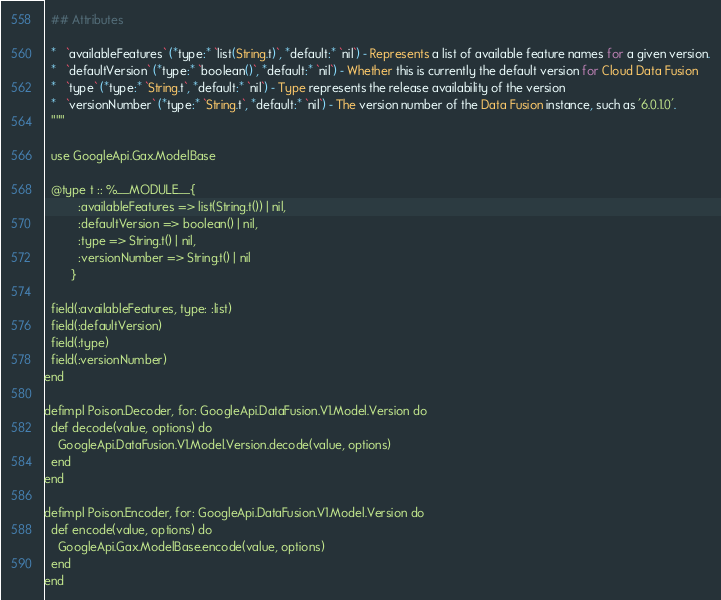<code> <loc_0><loc_0><loc_500><loc_500><_Elixir_>  ## Attributes

  *   `availableFeatures` (*type:* `list(String.t)`, *default:* `nil`) - Represents a list of available feature names for a given version.
  *   `defaultVersion` (*type:* `boolean()`, *default:* `nil`) - Whether this is currently the default version for Cloud Data Fusion
  *   `type` (*type:* `String.t`, *default:* `nil`) - Type represents the release availability of the version
  *   `versionNumber` (*type:* `String.t`, *default:* `nil`) - The version number of the Data Fusion instance, such as '6.0.1.0'.
  """

  use GoogleApi.Gax.ModelBase

  @type t :: %__MODULE__{
          :availableFeatures => list(String.t()) | nil,
          :defaultVersion => boolean() | nil,
          :type => String.t() | nil,
          :versionNumber => String.t() | nil
        }

  field(:availableFeatures, type: :list)
  field(:defaultVersion)
  field(:type)
  field(:versionNumber)
end

defimpl Poison.Decoder, for: GoogleApi.DataFusion.V1.Model.Version do
  def decode(value, options) do
    GoogleApi.DataFusion.V1.Model.Version.decode(value, options)
  end
end

defimpl Poison.Encoder, for: GoogleApi.DataFusion.V1.Model.Version do
  def encode(value, options) do
    GoogleApi.Gax.ModelBase.encode(value, options)
  end
end
</code> 